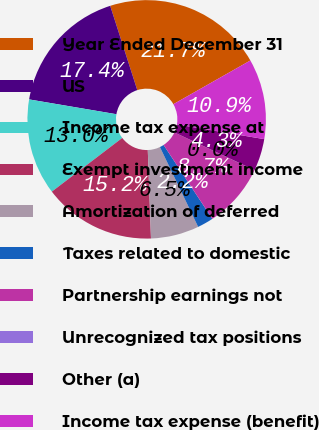<chart> <loc_0><loc_0><loc_500><loc_500><pie_chart><fcel>Year Ended December 31<fcel>US<fcel>Income tax expense at<fcel>Exempt investment income<fcel>Amortization of deferred<fcel>Taxes related to domestic<fcel>Partnership earnings not<fcel>Unrecognized tax positions<fcel>Other (a)<fcel>Income tax expense (benefit)<nl><fcel>21.73%<fcel>17.38%<fcel>13.04%<fcel>15.21%<fcel>6.53%<fcel>2.18%<fcel>8.7%<fcel>0.01%<fcel>4.35%<fcel>10.87%<nl></chart> 